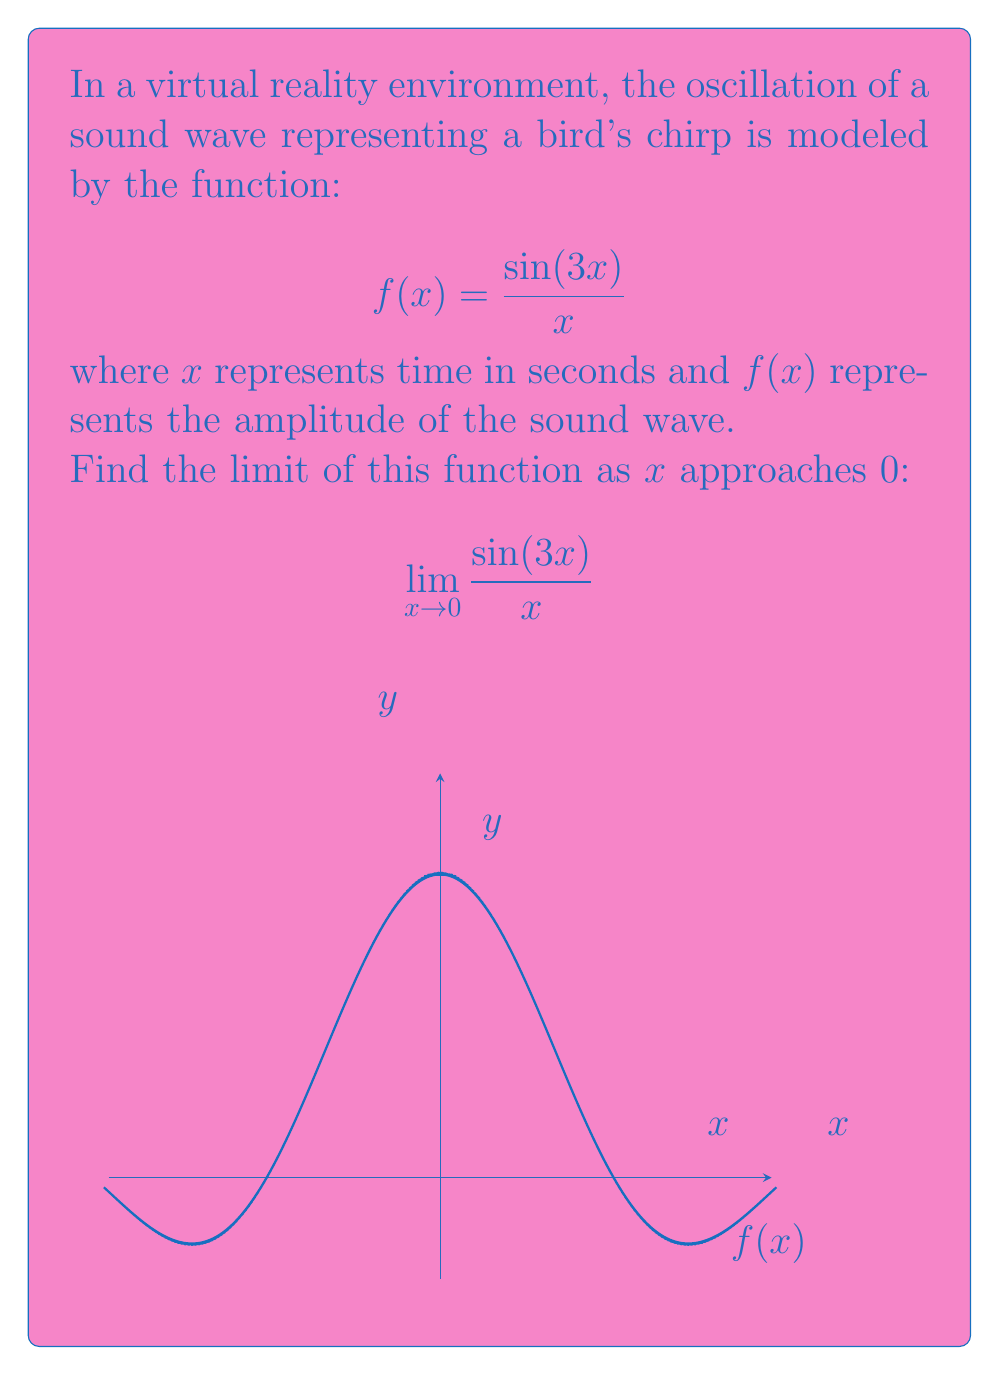Provide a solution to this math problem. To find this limit, we'll use the following steps:

1) First, we recognize that this is a limit of the form $\frac{\sin(kx)}{x}$ as $x$ approaches 0, where $k$ is a constant (in this case, $k=3$).

2) We know from the limit of the sine function that:

   $$\lim_{x \to 0} \frac{\sin(x)}{x} = 1$$

3) To use this, we need to manipulate our function:

   $$\lim_{x \to 0} \frac{\sin(3x)}{x} = \lim_{x \to 0} 3 \cdot \frac{\sin(3x)}{3x}$$

4) Now we can make a substitution. Let $u = 3x$. As $x \to 0$, $u \to 0$ as well.

   $$\lim_{u \to 0} 3 \cdot \frac{\sin(u)}{u}$$

5) We can now apply the limit of the sine function:

   $$3 \cdot \lim_{u \to 0} \frac{\sin(u)}{u} = 3 \cdot 1 = 3$$

Thus, the limit of the function as $x$ approaches 0 is 3.

This result indicates that as time approaches 0, the amplitude of the sound wave converges to 3, which represents the initial peak of the bird's chirp in our virtual reality environment.
Answer: $3$ 